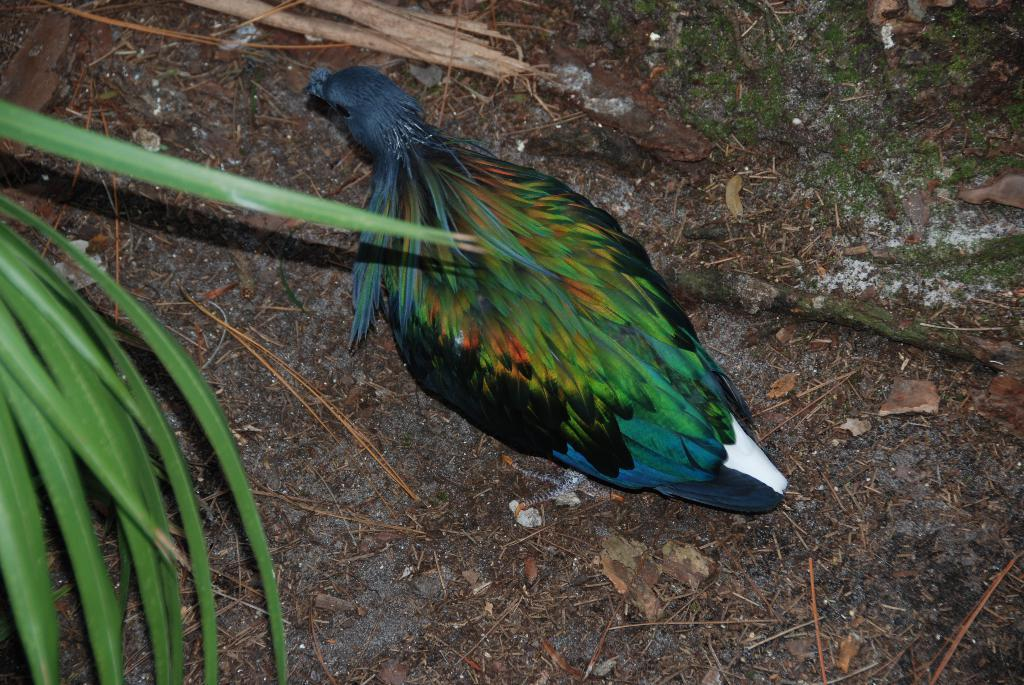What is the main subject in the center of the image? There is a bird in the center of the image. What type of vegetation can be seen on the left side of the image? There are leaves on the left side of the image. What type of surface is visible at the bottom of the image? There is ground visible at the bottom of the image. What type of vessel is being used to serve the orange pies in the image? There is no vessel or orange pies present in the image; it features a bird and leaves. 